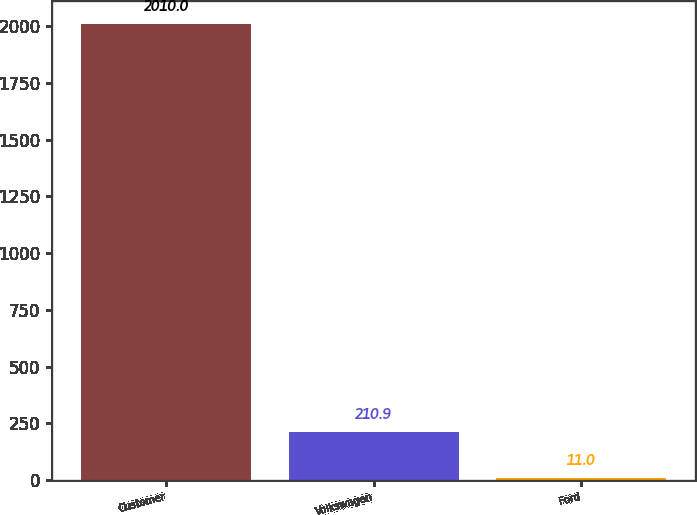Convert chart to OTSL. <chart><loc_0><loc_0><loc_500><loc_500><bar_chart><fcel>Customer<fcel>Volkswagen<fcel>Ford<nl><fcel>2010<fcel>210.9<fcel>11<nl></chart> 